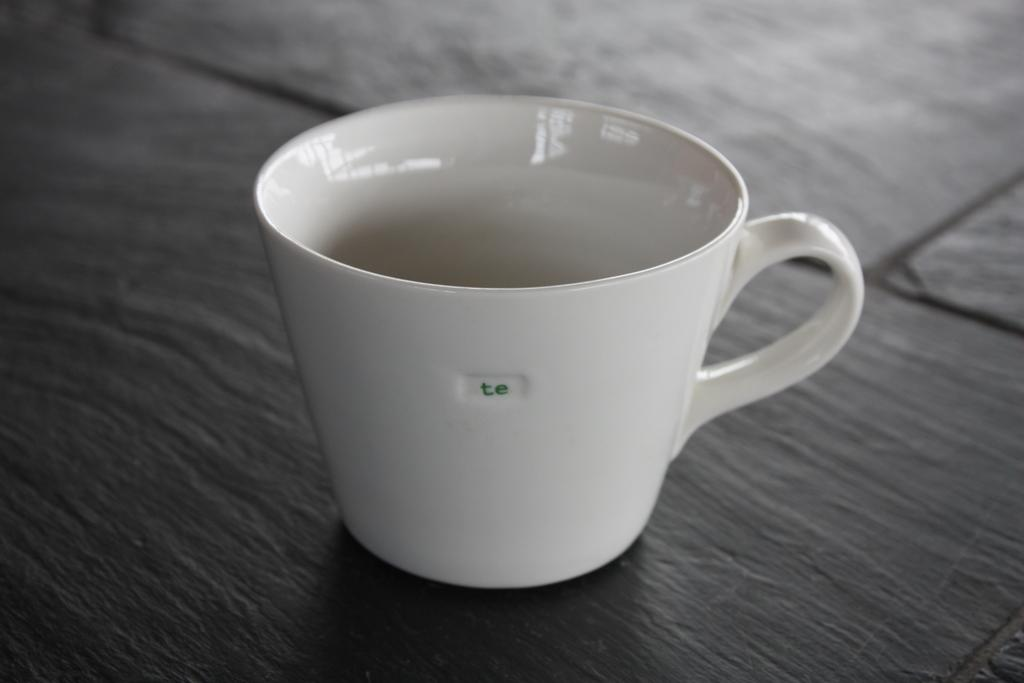<image>
Create a compact narrative representing the image presented. A small ceramic mug with the word te on it. 